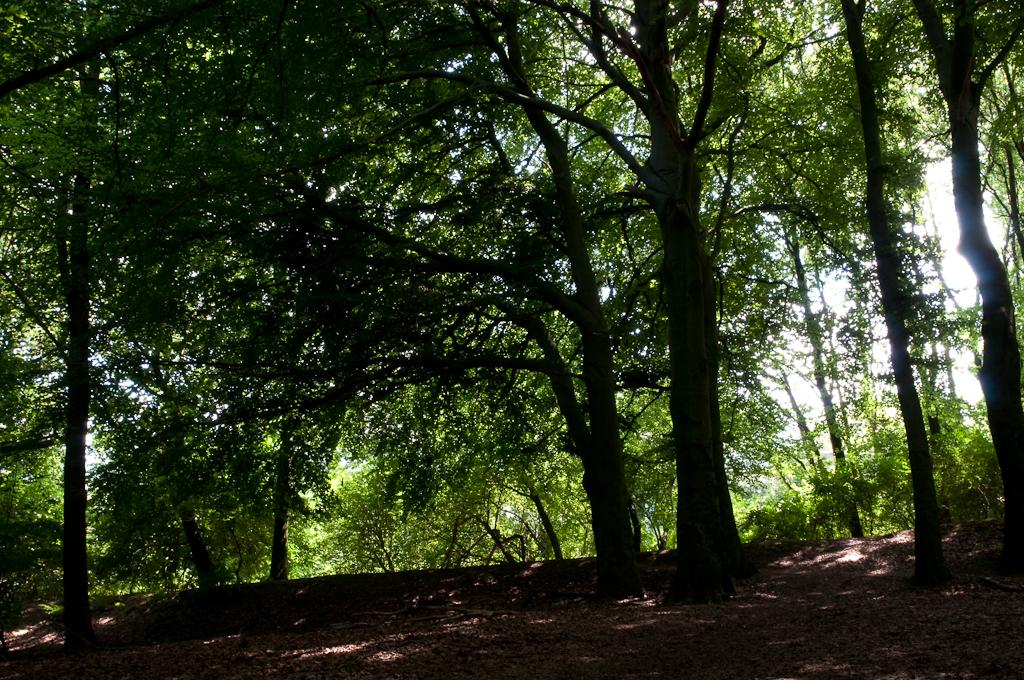What type of vegetation can be seen in the image? There are trees in the image. Where are the trees located? The trees are located on the land. What type of sheet is covering the trees in the image? There is no sheet covering the trees in the image; the trees are visible and not obstructed. 